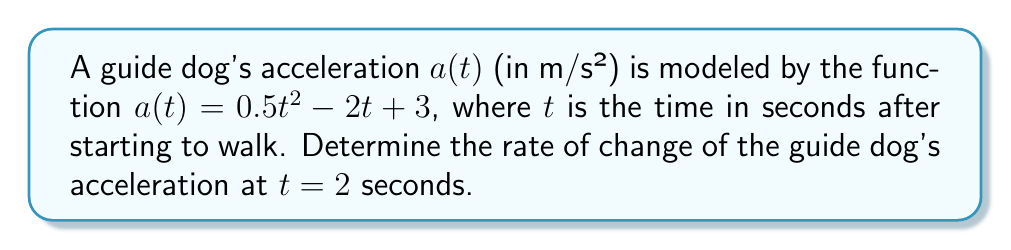What is the answer to this math problem? To find the rate of change of acceleration, we need to calculate the derivative of the acceleration function $a(t)$.

1. Given acceleration function: $a(t) = 0.5t^2 - 2t + 3$

2. To find the rate of change, we need to differentiate $a(t)$ with respect to $t$:
   $$\frac{d}{dt}a(t) = \frac{d}{dt}(0.5t^2 - 2t + 3)$$

3. Using the power rule and constant rule of differentiation:
   $$\frac{d}{dt}a(t) = 0.5 \cdot 2t^{2-1} - 2 + 0$$
   $$\frac{d}{dt}a(t) = t - 2$$

4. This function $\frac{d}{dt}a(t) = t - 2$ represents the rate of change of acceleration, also known as jerk.

5. To find the rate of change at $t = 2$ seconds, we substitute $t = 2$ into the derivative function:
   $$\frac{d}{dt}a(2) = 2 - 2 = 0$$

Therefore, the rate of change of the guide dog's acceleration at $t = 2$ seconds is 0 m/s³.
Answer: 0 m/s³ 